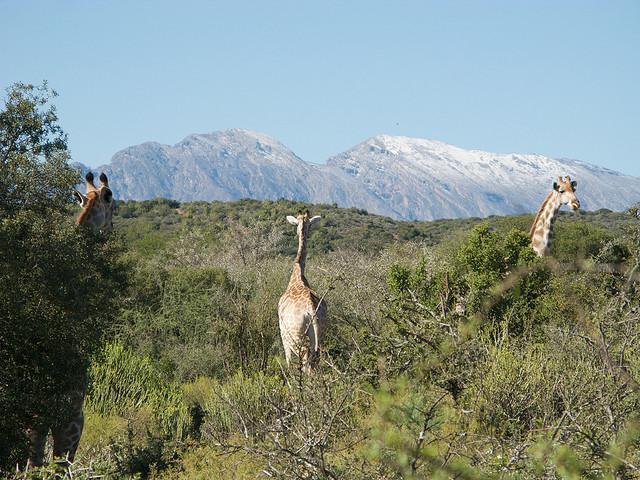How many animals are visible?
Give a very brief answer. 3. 